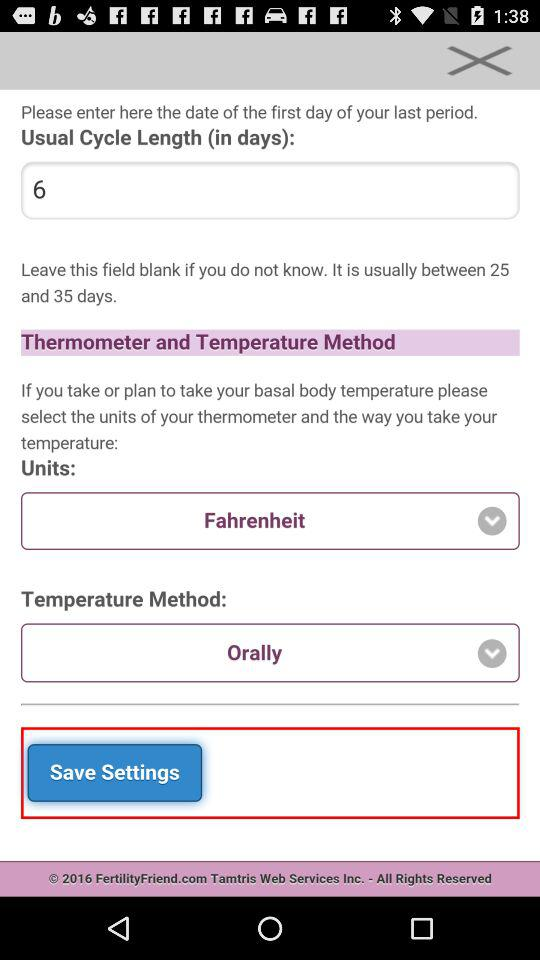What is the unit selected for temperature measurement in "Thermometer and Temperature Method"? The unit selected for temperature measurement in "Thermometer and Temperature Method" is Fahrenheit. 